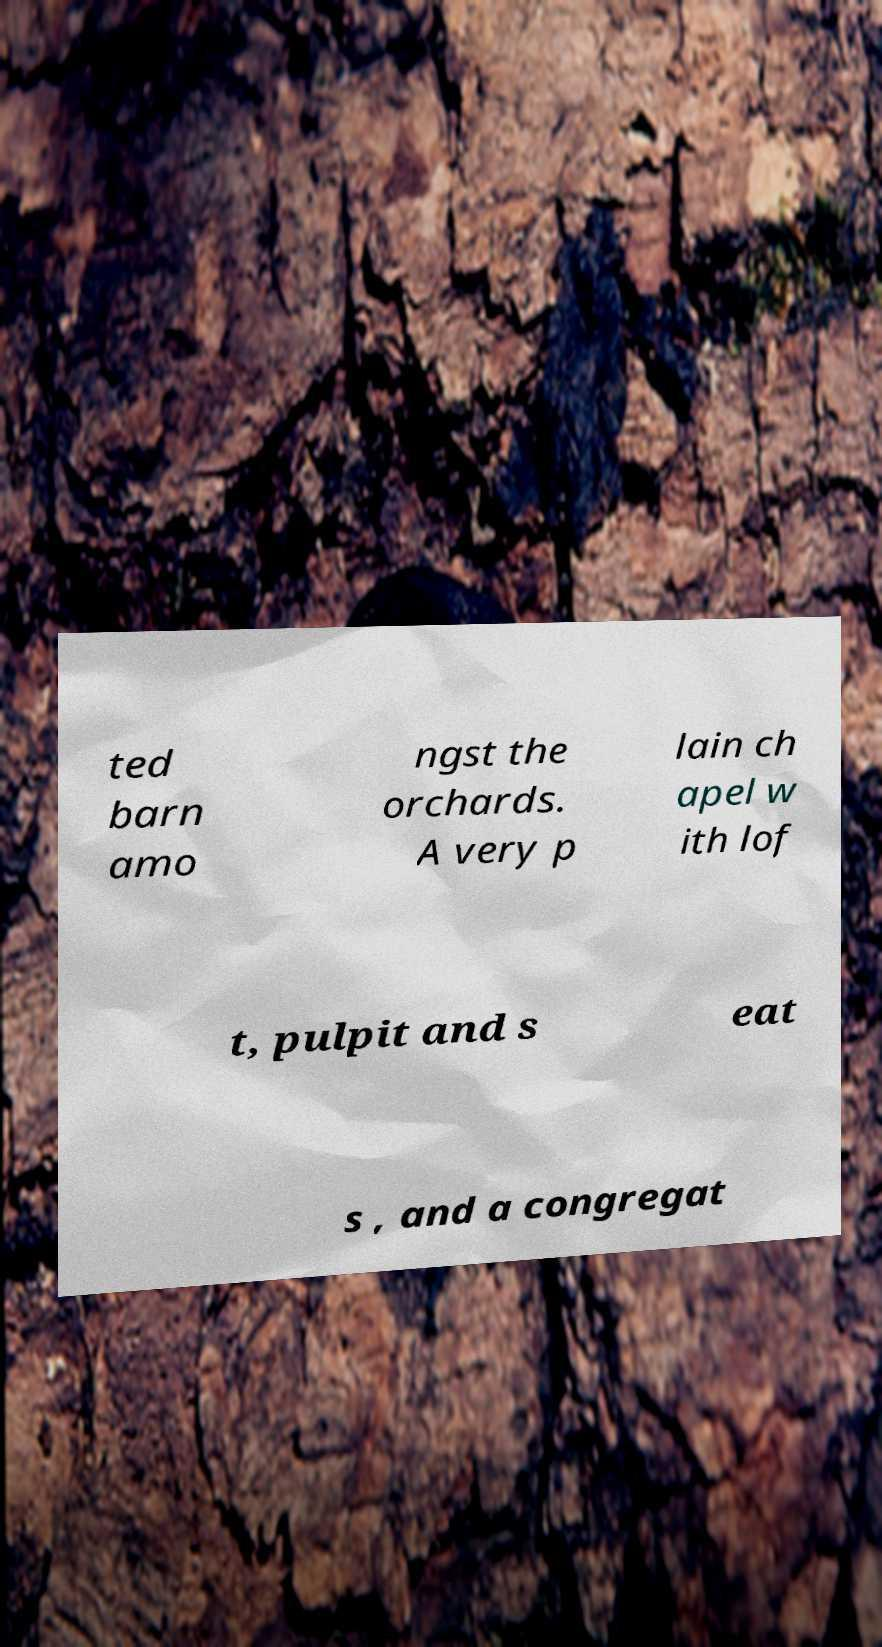Can you accurately transcribe the text from the provided image for me? ted barn amo ngst the orchards. A very p lain ch apel w ith lof t, pulpit and s eat s , and a congregat 